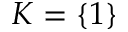<formula> <loc_0><loc_0><loc_500><loc_500>K = \{ 1 \}</formula> 